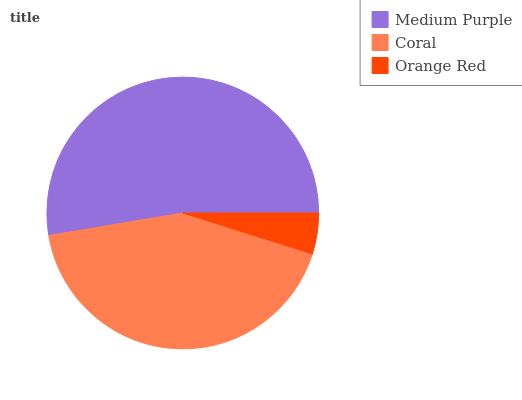Is Orange Red the minimum?
Answer yes or no. Yes. Is Medium Purple the maximum?
Answer yes or no. Yes. Is Coral the minimum?
Answer yes or no. No. Is Coral the maximum?
Answer yes or no. No. Is Medium Purple greater than Coral?
Answer yes or no. Yes. Is Coral less than Medium Purple?
Answer yes or no. Yes. Is Coral greater than Medium Purple?
Answer yes or no. No. Is Medium Purple less than Coral?
Answer yes or no. No. Is Coral the high median?
Answer yes or no. Yes. Is Coral the low median?
Answer yes or no. Yes. Is Medium Purple the high median?
Answer yes or no. No. Is Orange Red the low median?
Answer yes or no. No. 